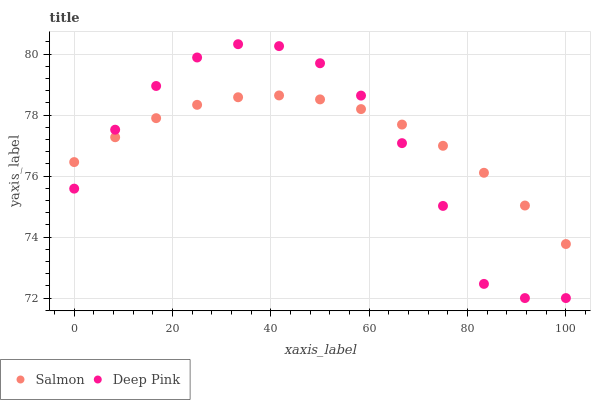Does Deep Pink have the minimum area under the curve?
Answer yes or no. Yes. Does Salmon have the maximum area under the curve?
Answer yes or no. Yes. Does Salmon have the minimum area under the curve?
Answer yes or no. No. Is Salmon the smoothest?
Answer yes or no. Yes. Is Deep Pink the roughest?
Answer yes or no. Yes. Is Salmon the roughest?
Answer yes or no. No. Does Deep Pink have the lowest value?
Answer yes or no. Yes. Does Salmon have the lowest value?
Answer yes or no. No. Does Deep Pink have the highest value?
Answer yes or no. Yes. Does Salmon have the highest value?
Answer yes or no. No. Does Deep Pink intersect Salmon?
Answer yes or no. Yes. Is Deep Pink less than Salmon?
Answer yes or no. No. Is Deep Pink greater than Salmon?
Answer yes or no. No. 